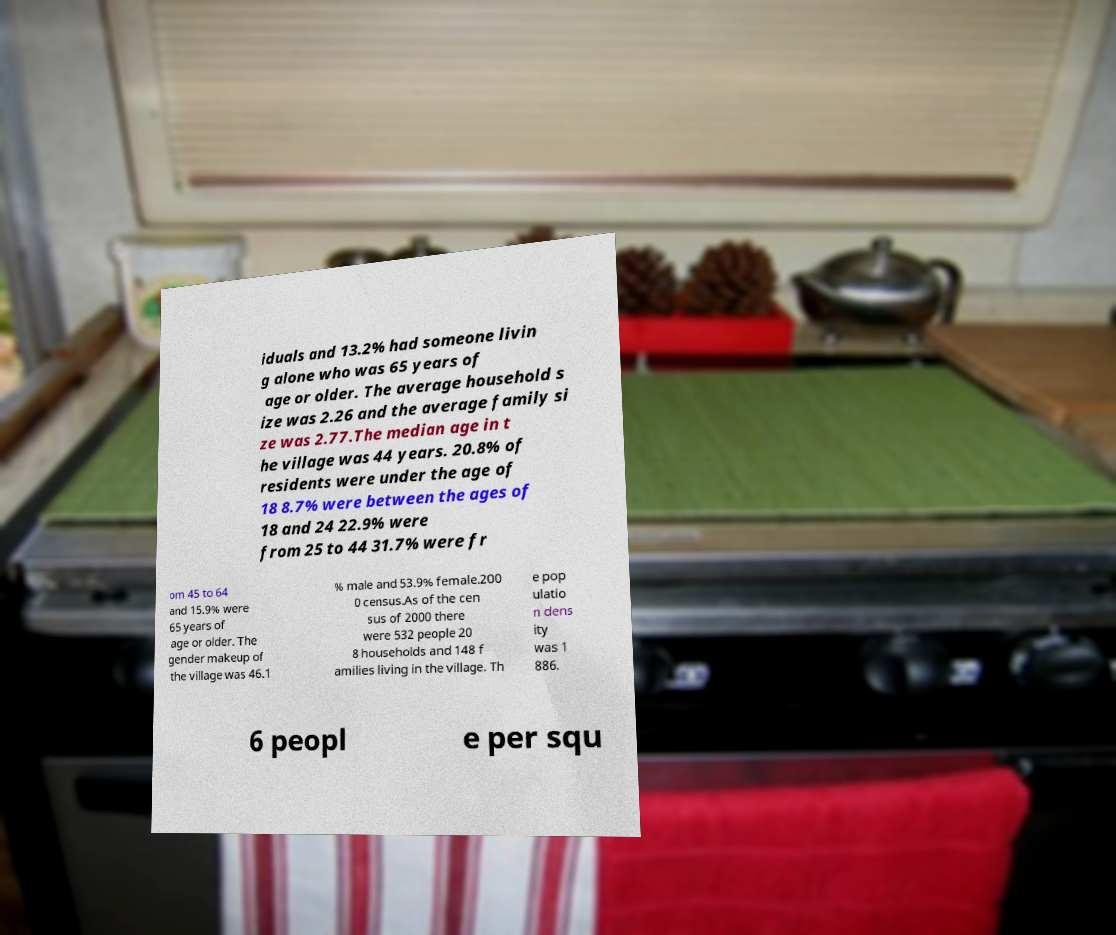There's text embedded in this image that I need extracted. Can you transcribe it verbatim? iduals and 13.2% had someone livin g alone who was 65 years of age or older. The average household s ize was 2.26 and the average family si ze was 2.77.The median age in t he village was 44 years. 20.8% of residents were under the age of 18 8.7% were between the ages of 18 and 24 22.9% were from 25 to 44 31.7% were fr om 45 to 64 and 15.9% were 65 years of age or older. The gender makeup of the village was 46.1 % male and 53.9% female.200 0 census.As of the cen sus of 2000 there were 532 people 20 8 households and 148 f amilies living in the village. Th e pop ulatio n dens ity was 1 886. 6 peopl e per squ 